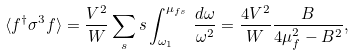Convert formula to latex. <formula><loc_0><loc_0><loc_500><loc_500>\langle f ^ { \dagger } \sigma ^ { 3 } f \rangle = \frac { V ^ { 2 } } { W } \sum _ { s } s \int _ { \omega _ { 1 } } ^ { \mu _ { f s } } \, \frac { d \omega } { \omega ^ { 2 } } = \frac { 4 V ^ { 2 } } { W } \frac { B } { 4 \mu _ { f } ^ { 2 } - B ^ { 2 } } ,</formula> 